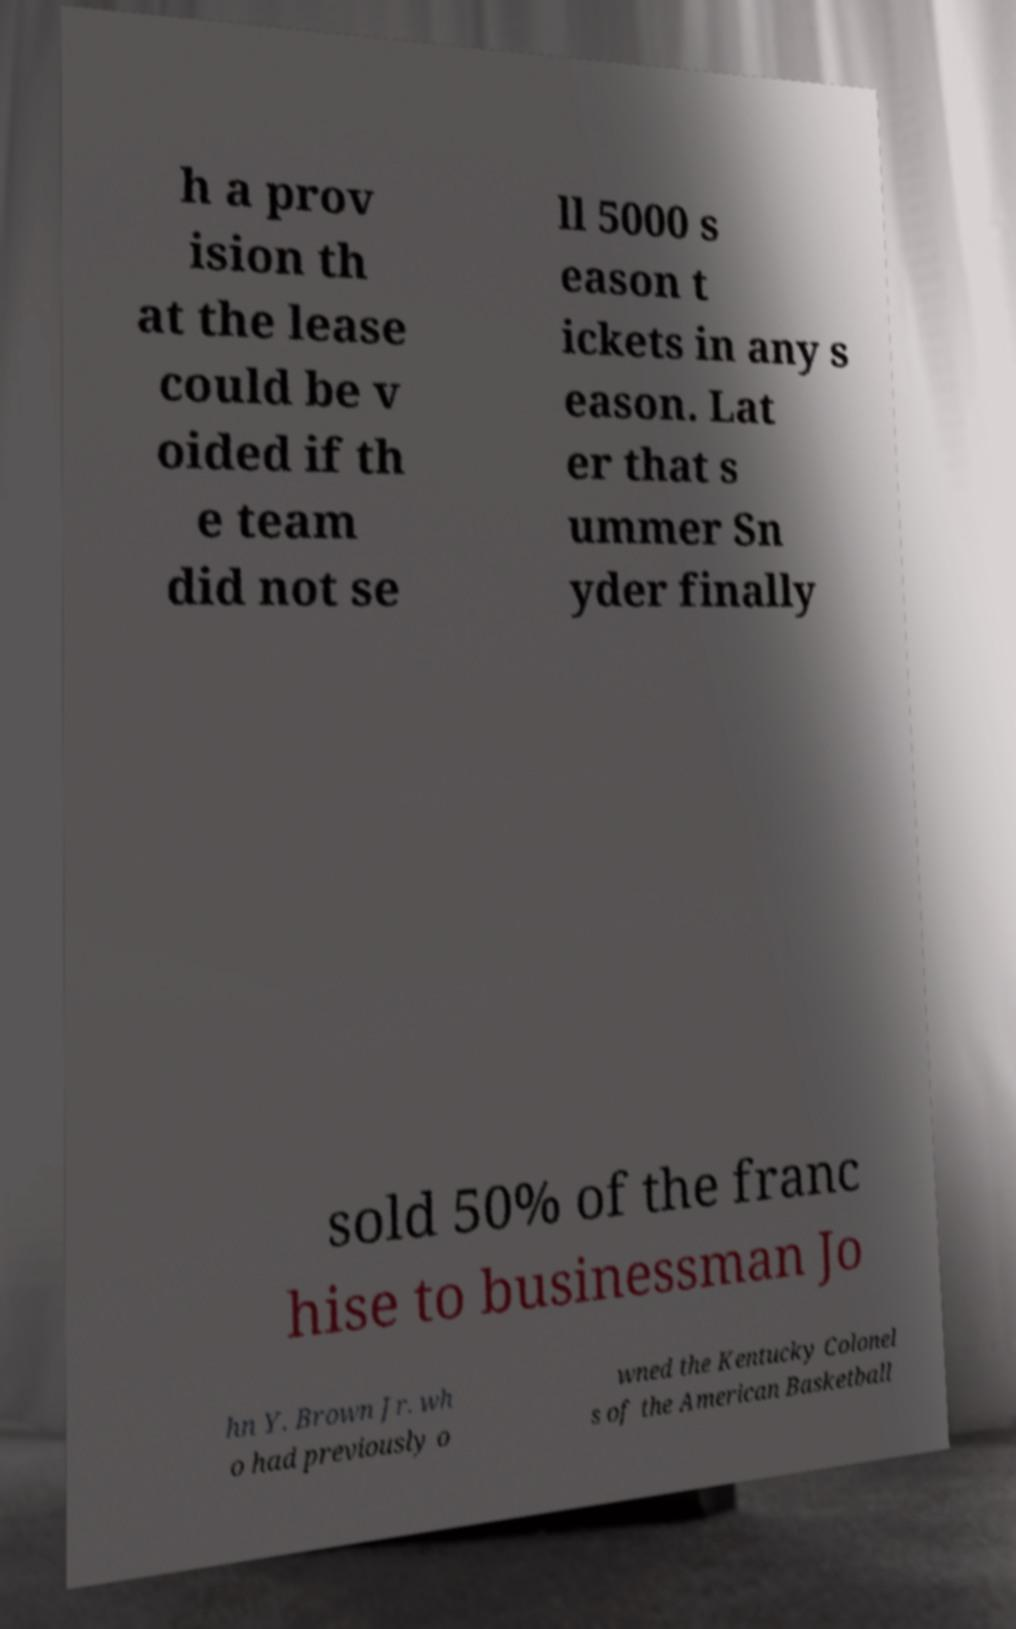Could you assist in decoding the text presented in this image and type it out clearly? h a prov ision th at the lease could be v oided if th e team did not se ll 5000 s eason t ickets in any s eason. Lat er that s ummer Sn yder finally sold 50% of the franc hise to businessman Jo hn Y. Brown Jr. wh o had previously o wned the Kentucky Colonel s of the American Basketball 